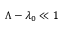Convert formula to latex. <formula><loc_0><loc_0><loc_500><loc_500>\Lambda - \lambda _ { 0 } \ll 1</formula> 